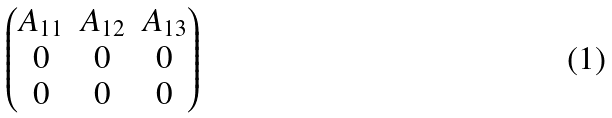<formula> <loc_0><loc_0><loc_500><loc_500>\begin{pmatrix} A _ { 1 1 } & A _ { 1 2 } & A _ { 1 3 } \\ 0 & 0 & 0 \\ 0 & 0 & 0 \\ \end{pmatrix}</formula> 